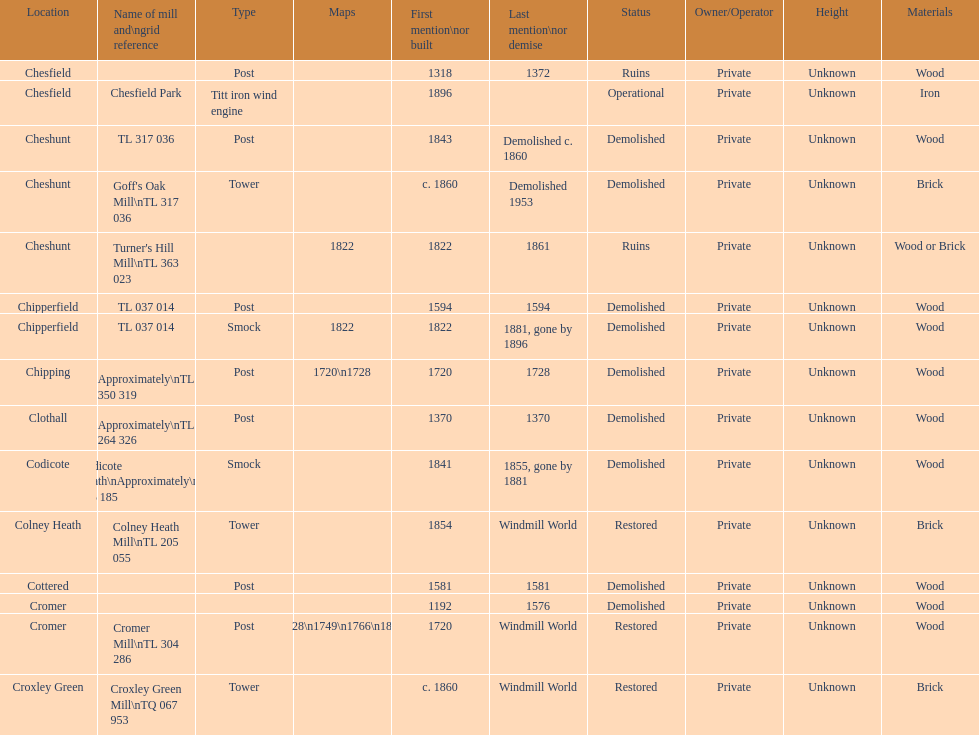Write the full table. {'header': ['Location', 'Name of mill and\\ngrid reference', 'Type', 'Maps', 'First mention\\nor built', 'Last mention\\nor demise', 'Status', 'Owner/Operator', 'Height', 'Materials'], 'rows': [['Chesfield', '', 'Post', '', '1318', '1372', 'Ruins', 'Private', 'Unknown', 'Wood'], ['Chesfield', 'Chesfield Park', 'Titt iron wind engine', '', '1896', '', 'Operational', 'Private', 'Unknown', 'Iron'], ['Cheshunt', 'TL 317 036', 'Post', '', '1843', 'Demolished c. 1860', 'Demolished', 'Private', 'Unknown', 'Wood'], ['Cheshunt', "Goff's Oak Mill\\nTL 317 036", 'Tower', '', 'c. 1860', 'Demolished 1953', 'Demolished', 'Private', 'Unknown', 'Brick'], ['Cheshunt', "Turner's Hill Mill\\nTL 363 023", '', '1822', '1822', '1861', 'Ruins', 'Private', 'Unknown', 'Wood or Brick'], ['Chipperfield', 'TL 037 014', 'Post', '', '1594', '1594', 'Demolished', 'Private', 'Unknown', 'Wood'], ['Chipperfield', 'TL 037 014', 'Smock', '1822', '1822', '1881, gone by 1896', 'Demolished', 'Private', 'Unknown', 'Wood'], ['Chipping', 'Approximately\\nTL 350 319', 'Post', '1720\\n1728', '1720', '1728', 'Demolished', 'Private', 'Unknown', 'Wood'], ['Clothall', 'Approximately\\nTL 264 326', 'Post', '', '1370', '1370', 'Demolished', 'Private', 'Unknown', 'Wood'], ['Codicote', 'Codicote Heath\\nApproximately\\nTL 206 185', 'Smock', '', '1841', '1855, gone by 1881', 'Demolished', 'Private', 'Unknown', 'Wood'], ['Colney Heath', 'Colney Heath Mill\\nTL 205 055', 'Tower', '', '1854', 'Windmill World', 'Restored', 'Private', 'Unknown', 'Brick'], ['Cottered', '', 'Post', '', '1581', '1581', 'Demolished', 'Private', 'Unknown', 'Wood'], ['Cromer', '', '', '', '1192', '1576', 'Demolished', 'Private', 'Unknown', 'Wood'], ['Cromer', 'Cromer Mill\\nTL 304 286', 'Post', '1720\\n1728\\n1749\\n1766\\n1800\\n1822', '1720', 'Windmill World', 'Restored', 'Private', 'Unknown', 'Wood'], ['Croxley Green', 'Croxley Green Mill\\nTQ 067 953', 'Tower', '', 'c. 1860', 'Windmill World', 'Restored', 'Private', 'Unknown', 'Brick']]} How many locations have no photograph? 14. 